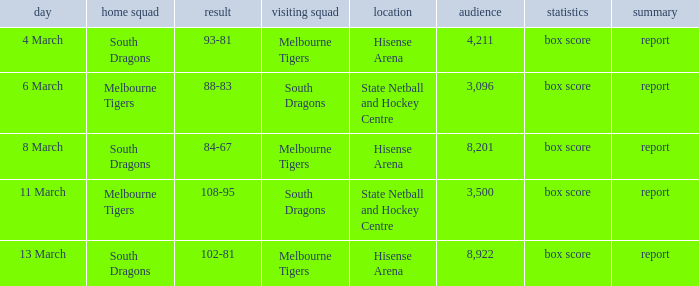Where was the venue with 3,096 in the crowd and against the Melbourne Tigers? Hisense Arena, Hisense Arena, Hisense Arena. 